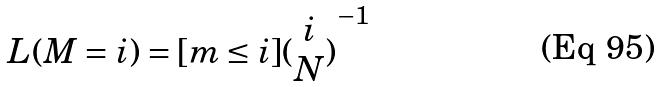Convert formula to latex. <formula><loc_0><loc_0><loc_500><loc_500>L ( M = i ) = [ m \leq i ] { ( \begin{matrix} i \\ N \end{matrix} ) } ^ { - 1 }</formula> 